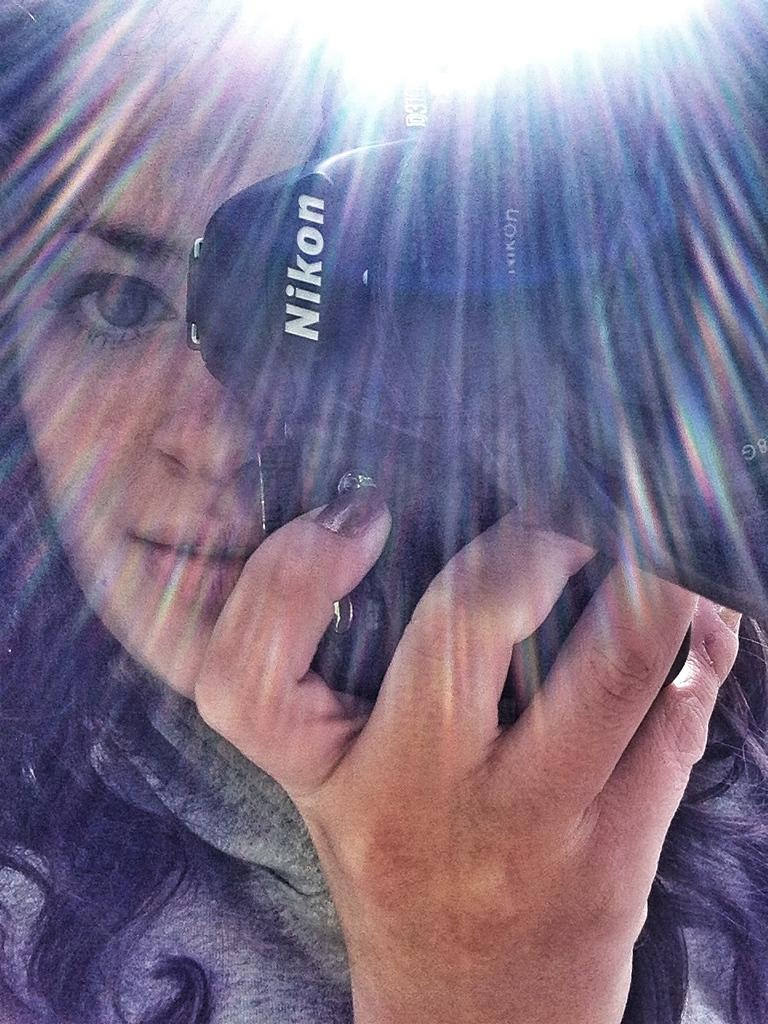<image>
Provide a brief description of the given image. A girl is holding a camera up to her face. The brand of the camera is Nikon. 